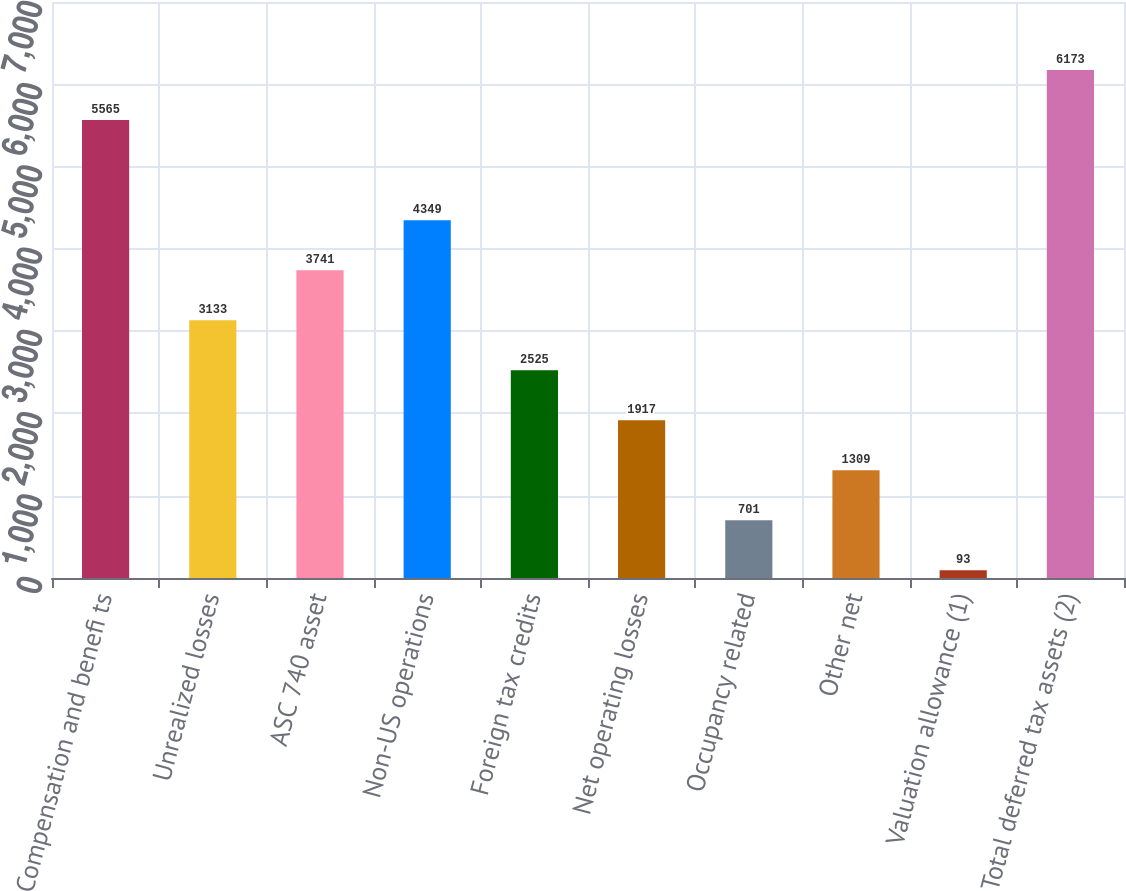<chart> <loc_0><loc_0><loc_500><loc_500><bar_chart><fcel>Compensation and benefi ts<fcel>Unrealized losses<fcel>ASC 740 asset<fcel>Non-US operations<fcel>Foreign tax credits<fcel>Net operating losses<fcel>Occupancy related<fcel>Other net<fcel>Valuation allowance (1)<fcel>Total deferred tax assets (2)<nl><fcel>5565<fcel>3133<fcel>3741<fcel>4349<fcel>2525<fcel>1917<fcel>701<fcel>1309<fcel>93<fcel>6173<nl></chart> 